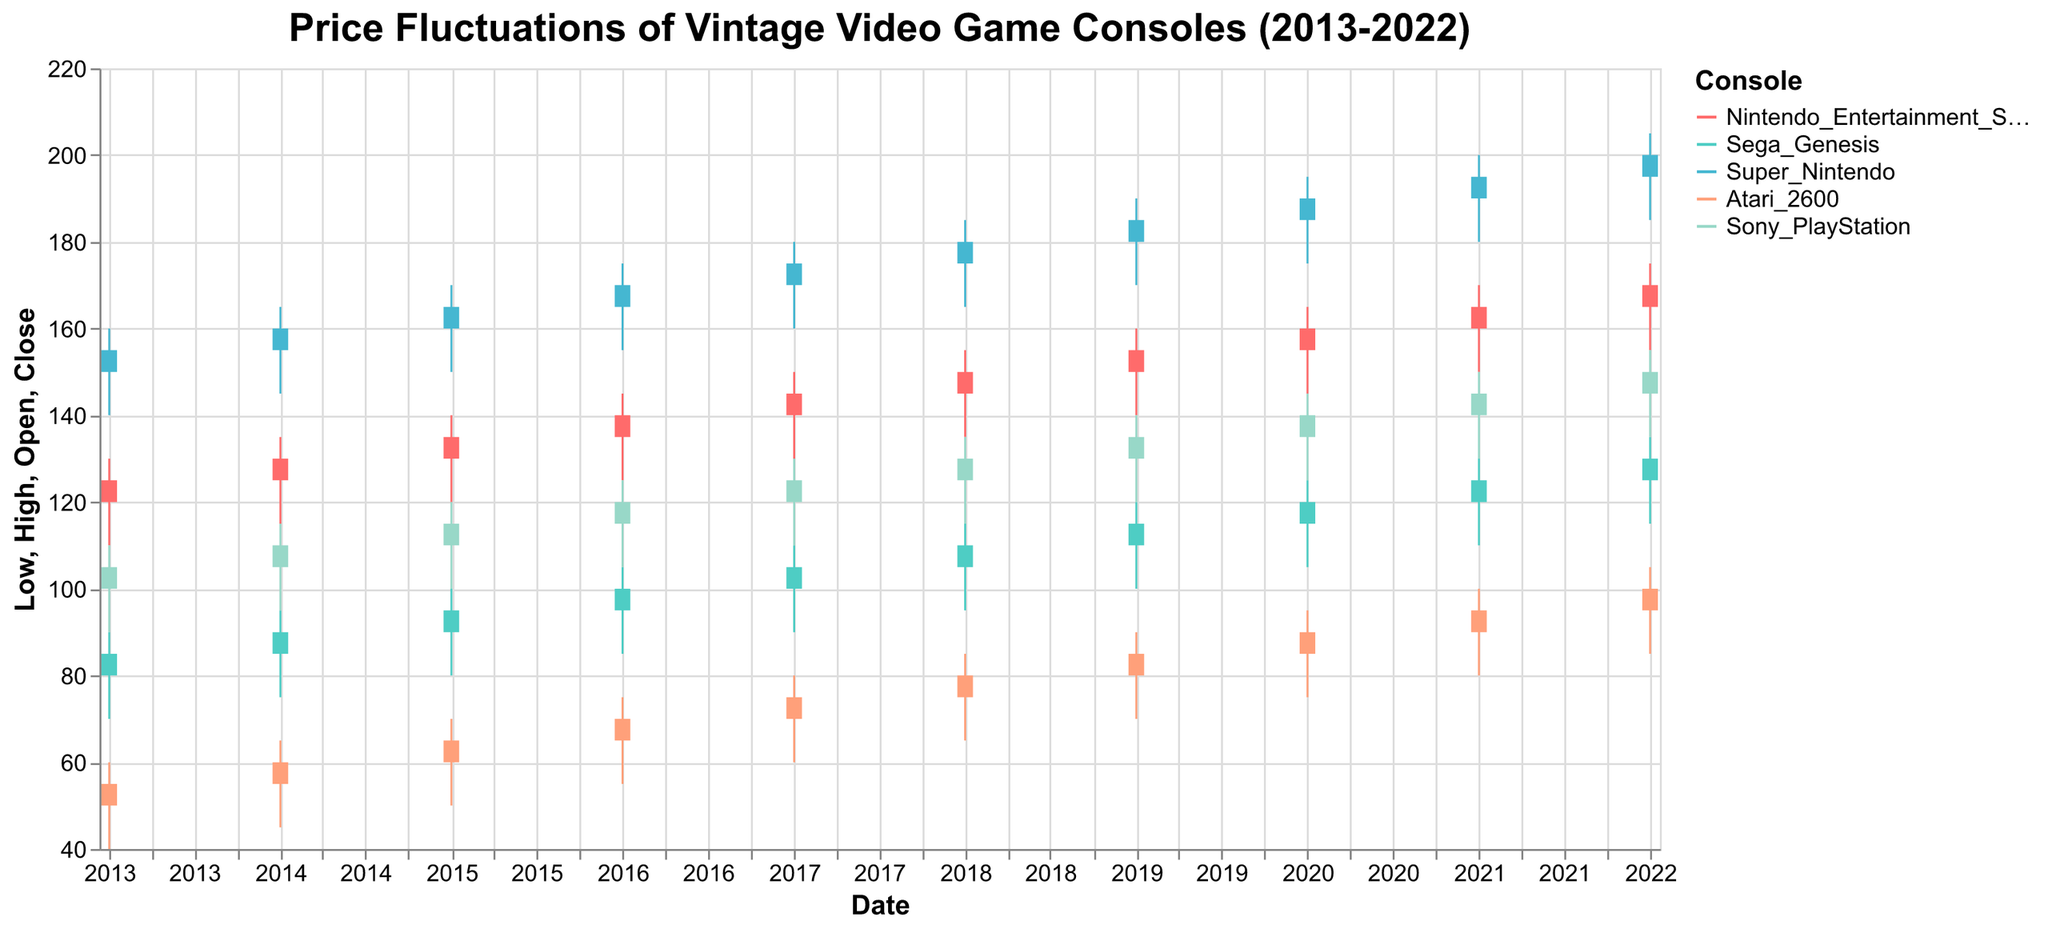What is the highest price ever recorded for the Sega Genesis over the decade? Look for the maximum high value for the Sega Genesis in the data provided. The highest high value for Sega Genesis was recorded in 2022 at $135.
Answer: $135 What was the closing price of the Sony PlayStation in 2015? Find the closing price of the Sony PlayStation in the year 2015. The closing price is $115.
Answer: $115 Which vintage console had the smallest price range in 2017? The price range is calculated by subtracting the low value from the high value for each console in 2017.
- Nintendo Entertainment System: 150 - 130 = 20
- Sega Genesis: 110 - 90 = 20
- Super Nintendo: 180 - 160 = 20
- Atari 2600: 80 - 60 = 20
- Sony PlayStation: 130 - 110 = 20
Since all consoles have the same range of 20, it's any of the listed ones.
Answer: All consoles Which console had a price close lower than its price open the most frequently? Review each console's data to check how many times the close price was lower than the open price.
- Nintendo Entertainment System: 0 times
- Sega Genesis: 0 times
- Super Nintendo: 0 times
- Atari 2600: 0 times
- Sony PlayStation: 0 times
All consoles had their close price higher than their open price every year.
Answer: None For the Atari 2600, what was the average of the closing prices over the decade? Average is calculated by summing the closing prices from 2013 to 2022 and dividing by 10.
Sum of closing prices: 55 + 60 + 65 + 70 + 75 + 80 + 85 + 90 + 95 + 100 = 775. The average is 775/10 = 77.5.
Answer: 77.5 Between 2013 and 2022, which console had the greatest overall price increase from the open value in 2013 to the close value in 2022? Calculate the difference between the open value in 2013 and the close value in 2022 for each console.
- Nintendo Entertainment System: 170 - 120 = 50
- Sega Genesis: 130 - 80 = 50
- Super Nintendo: 200 - 150 = 50
- Atari 2600: 100 - 50 = 50
- Sony PlayStation: 150 - 100 = 50
All consoles had the same overall price increase of 50.
Answer: All consoles What was the largest price fluctuation (high - low) for the Super Nintendo? Look for the largest difference between the high and low prices of the Super Nintendo over the decade. The biggest fluctuation was 205 - 185 = 20 in 2022.
Answer: 20 By how much did the closing price of the Nintendo Entertainment System increase from 2013 to 2022? Subtract the closing price in 2013 from the closing price in 2022. The increase is 170 - 125 = 45.
Answer: 45 